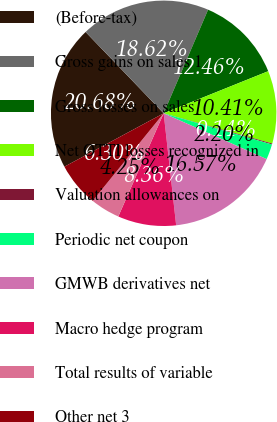Convert chart to OTSL. <chart><loc_0><loc_0><loc_500><loc_500><pie_chart><fcel>(Before-tax)<fcel>Gross gains on sales 1<fcel>Gross losses on sales<fcel>Net OTTI losses recognized in<fcel>Valuation allowances on<fcel>Periodic net coupon<fcel>GMWB derivatives net<fcel>Macro hedge program<fcel>Total results of variable<fcel>Other net 3<nl><fcel>20.68%<fcel>18.62%<fcel>12.46%<fcel>10.41%<fcel>0.14%<fcel>2.2%<fcel>16.57%<fcel>8.36%<fcel>4.25%<fcel>6.3%<nl></chart> 